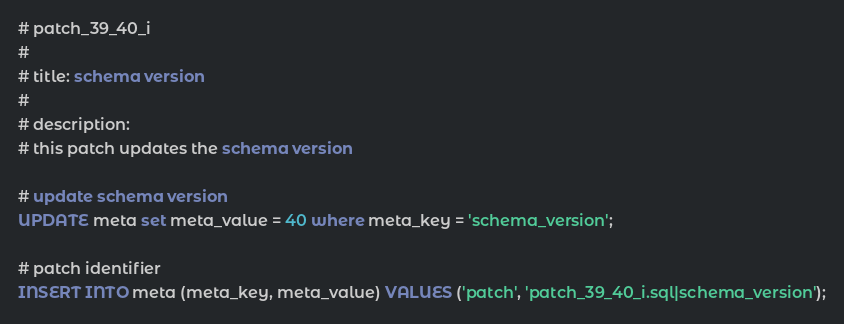Convert code to text. <code><loc_0><loc_0><loc_500><loc_500><_SQL_># patch_39_40_i
#
# title: schema version
#
# description:
# this patch updates the schema version

# update schema version
UPDATE meta set meta_value = 40 where meta_key = 'schema_version';

# patch identifier
INSERT INTO meta (meta_key, meta_value) VALUES ('patch', 'patch_39_40_i.sql|schema_version');

</code> 